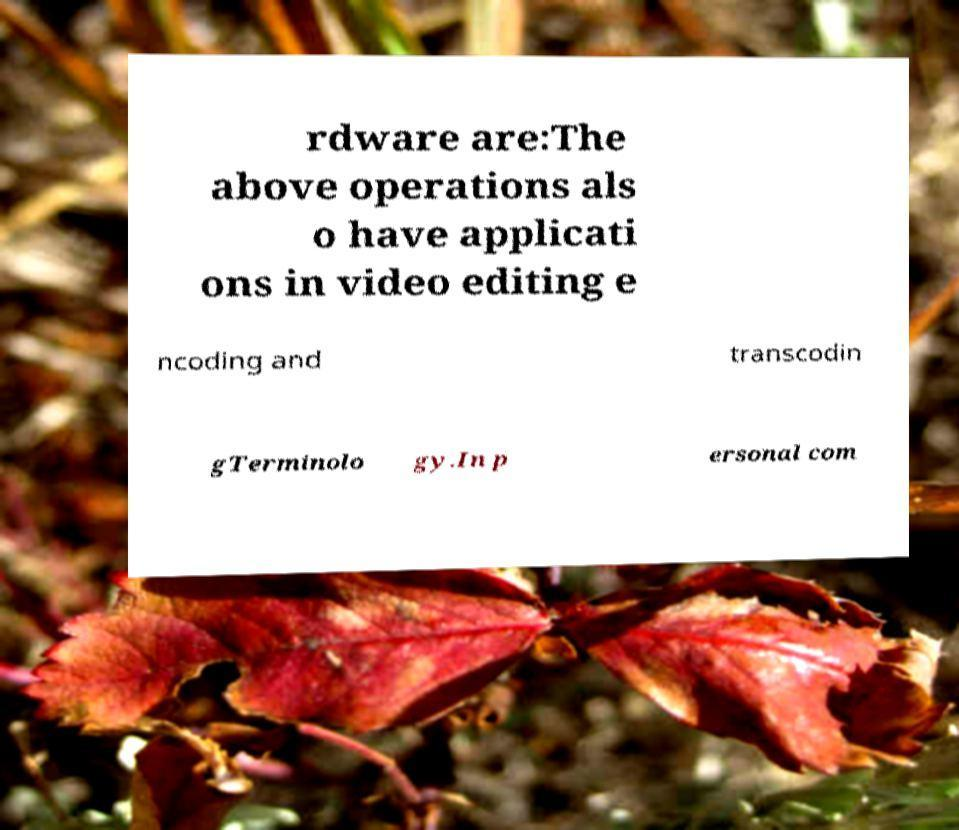Could you extract and type out the text from this image? rdware are:The above operations als o have applicati ons in video editing e ncoding and transcodin gTerminolo gy.In p ersonal com 